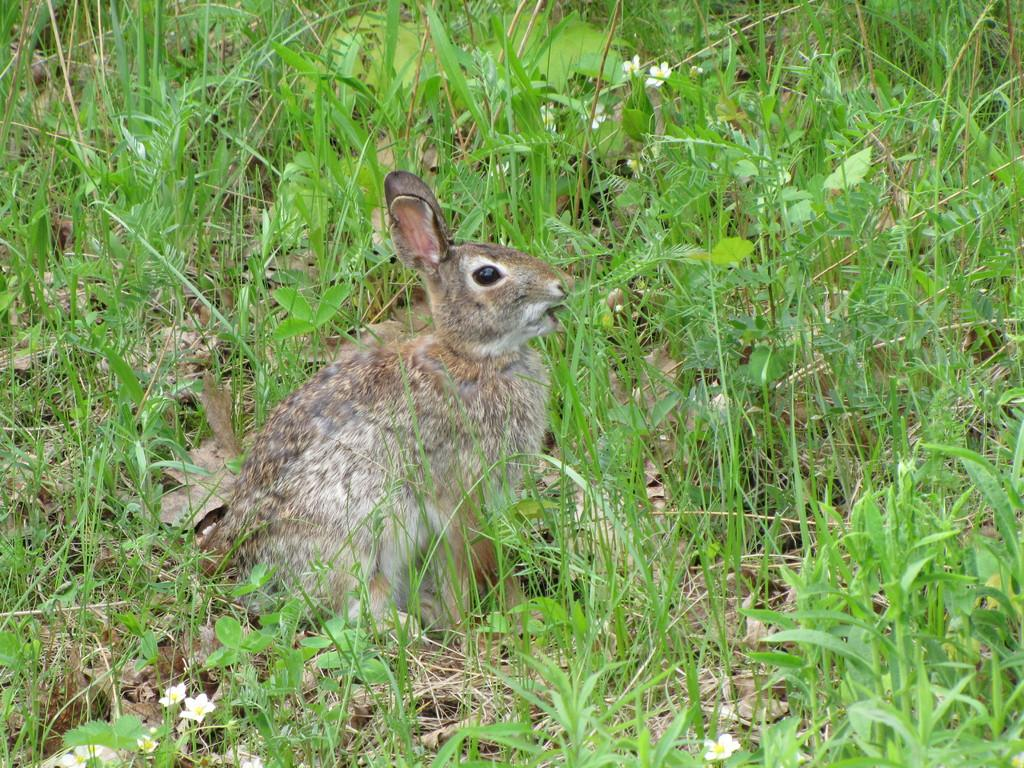What animal is present in the image? There is a rabbit in the image. What is the rabbit doing in the image? The rabbit is grazing in the image. Where is the rabbit located? The rabbit is in a field in the image. What type of feather can be seen on the rabbit in the image? There are no feathers present on the rabbit in the image, as rabbits have fur, not feathers. 